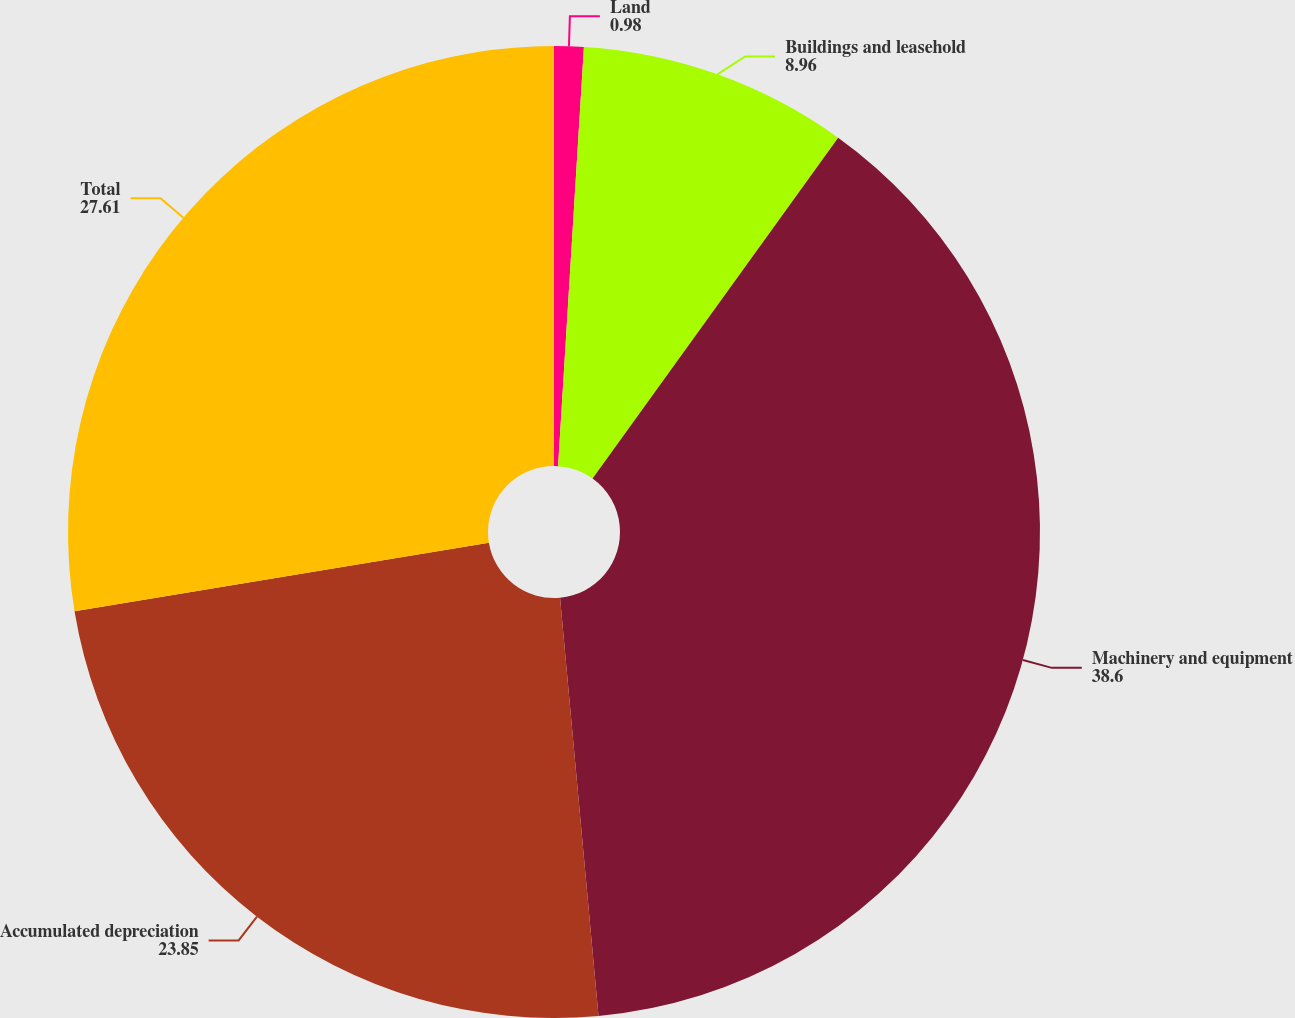<chart> <loc_0><loc_0><loc_500><loc_500><pie_chart><fcel>Land<fcel>Buildings and leasehold<fcel>Machinery and equipment<fcel>Accumulated depreciation<fcel>Total<nl><fcel>0.98%<fcel>8.96%<fcel>38.6%<fcel>23.85%<fcel>27.61%<nl></chart> 